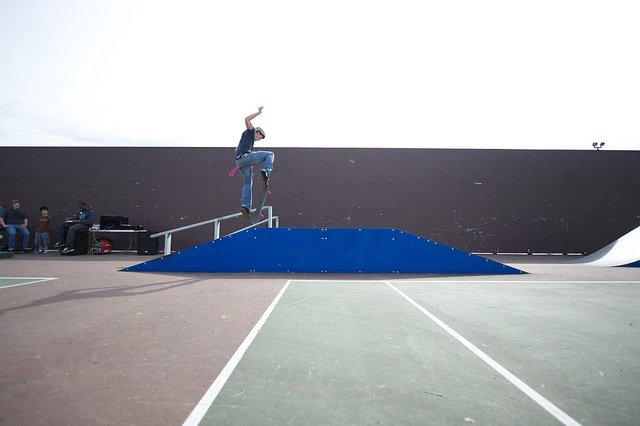Describe the objects in this image and their specific colors. I can see people in lavender, gray, blue, and navy tones, people in lavender, black, gray, and blue tones, people in lavender, black, navy, gray, and blue tones, people in lavender, black, navy, gray, and darkblue tones, and skateboard in lavender, gray, darkblue, and black tones in this image. 